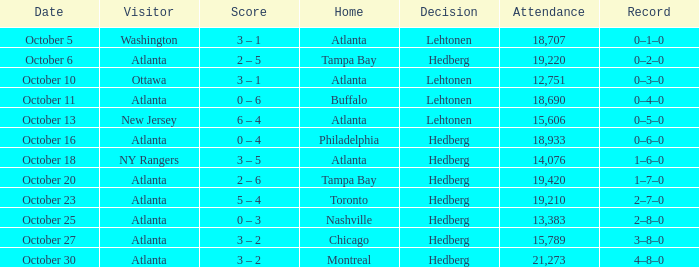What was the record on the game that was played on october 27? 3–8–0. 